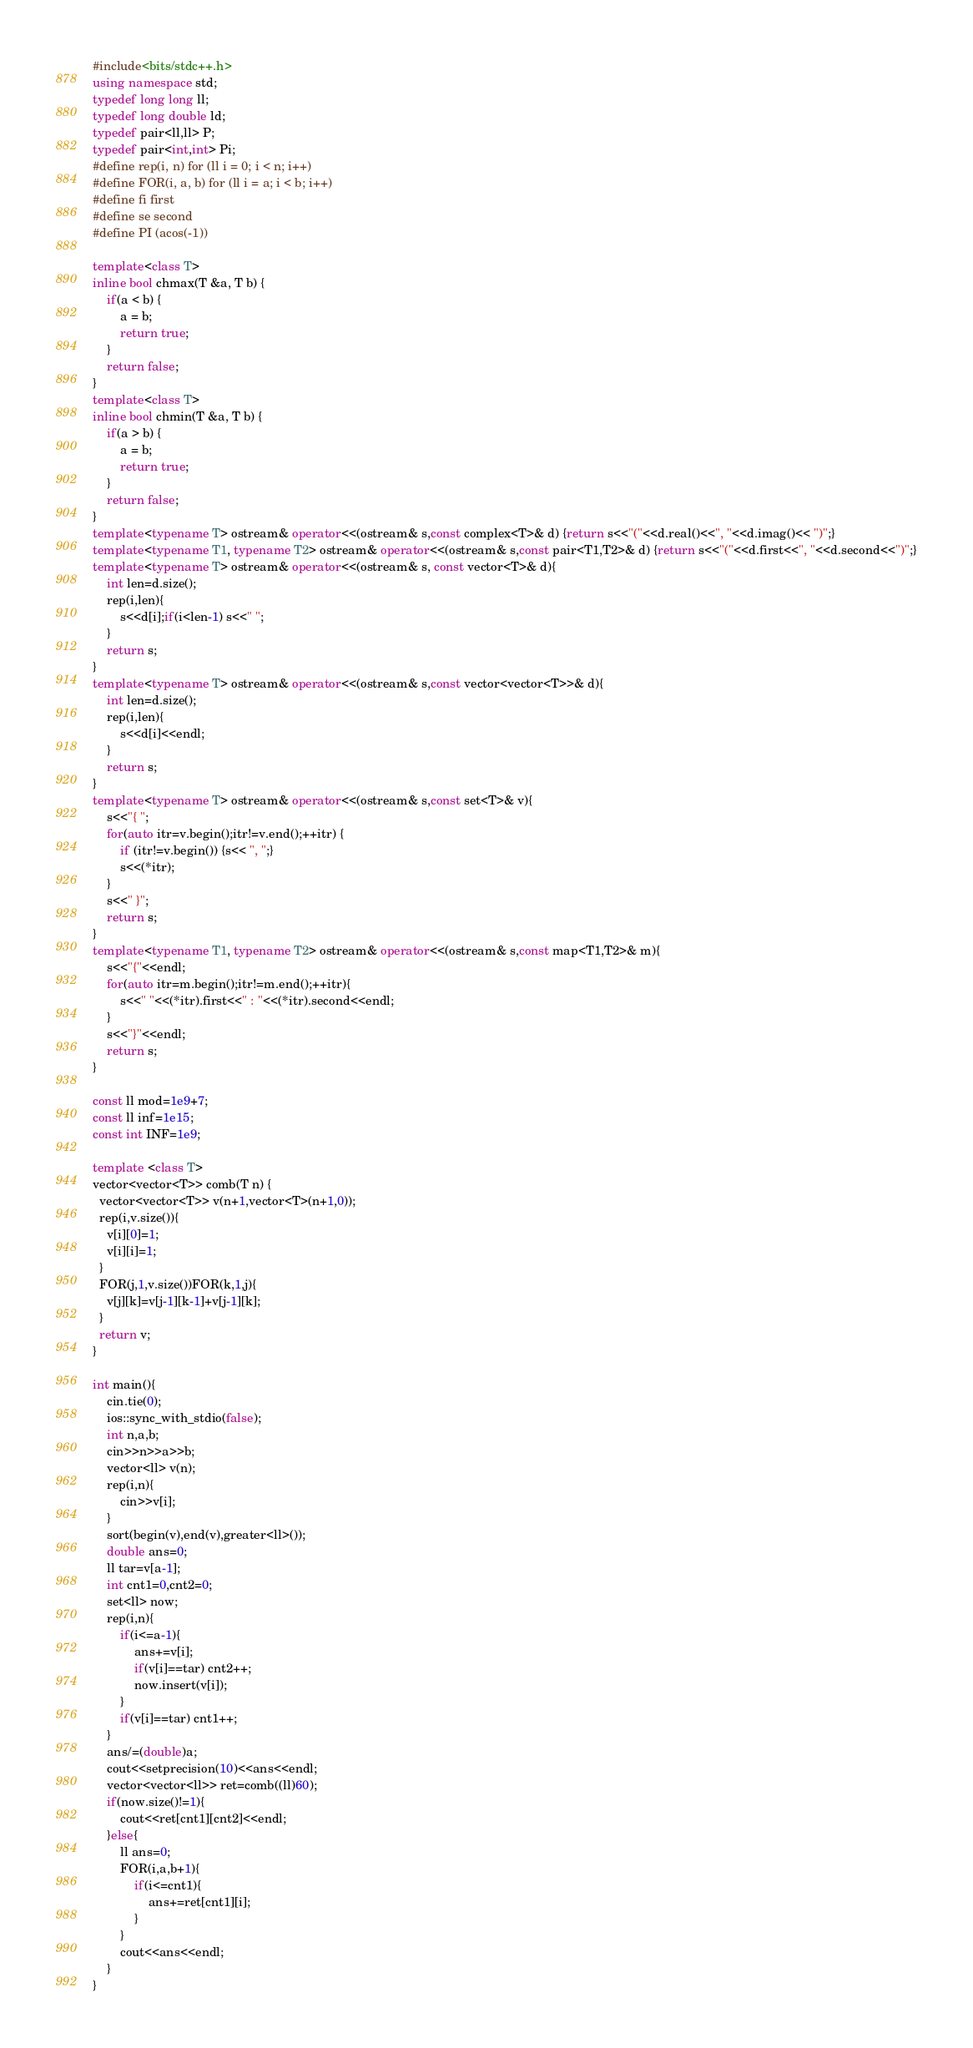<code> <loc_0><loc_0><loc_500><loc_500><_C++_>#include<bits/stdc++.h>
using namespace std;
typedef long long ll;
typedef long double ld;
typedef pair<ll,ll> P;
typedef pair<int,int> Pi;
#define rep(i, n) for (ll i = 0; i < n; i++)
#define FOR(i, a, b) for (ll i = a; i < b; i++)
#define fi first
#define se second
#define PI (acos(-1))

template<class T>
inline bool chmax(T &a, T b) {
    if(a < b) {
        a = b;
        return true;
    }
    return false;
}
template<class T>
inline bool chmin(T &a, T b) {
    if(a > b) {
        a = b;
        return true;
    }
    return false;
}
template<typename T> ostream& operator<<(ostream& s,const complex<T>& d) {return s<<"("<<d.real()<<", "<<d.imag()<< ")";}
template<typename T1, typename T2> ostream& operator<<(ostream& s,const pair<T1,T2>& d) {return s<<"("<<d.first<<", "<<d.second<<")";}
template<typename T> ostream& operator<<(ostream& s, const vector<T>& d){
	int len=d.size();
	rep(i,len){
		s<<d[i];if(i<len-1) s<<" ";
	}
	return s;
}
template<typename T> ostream& operator<<(ostream& s,const vector<vector<T>>& d){
	int len=d.size();
	rep(i,len){
		s<<d[i]<<endl;
	}
	return s;
}
template<typename T> ostream& operator<<(ostream& s,const set<T>& v){
	s<<"{ ";
	for(auto itr=v.begin();itr!=v.end();++itr) {
		if (itr!=v.begin()) {s<< ", ";}
		s<<(*itr);
	}
	s<<" }";
	return s;
}
template<typename T1, typename T2> ostream& operator<<(ostream& s,const map<T1,T2>& m){
	s<<"{"<<endl;
	for(auto itr=m.begin();itr!=m.end();++itr){
		s<<" "<<(*itr).first<<" : "<<(*itr).second<<endl;
	}
	s<<"}"<<endl;
	return s;
}

const ll mod=1e9+7;
const ll inf=1e15;
const int INF=1e9;

template <class T>
vector<vector<T>> comb(T n) {
  vector<vector<T>> v(n+1,vector<T>(n+1,0));
  rep(i,v.size()){
	v[i][0]=1;
	v[i][i]=1;
  }
  FOR(j,1,v.size())FOR(k,1,j){
	v[j][k]=v[j-1][k-1]+v[j-1][k];
  }
  return v;
}

int main(){
	cin.tie(0);
	ios::sync_with_stdio(false);
	int n,a,b;
	cin>>n>>a>>b;
	vector<ll> v(n);
	rep(i,n){
		cin>>v[i];
	}
	sort(begin(v),end(v),greater<ll>());
	double ans=0;
	ll tar=v[a-1];
	int cnt1=0,cnt2=0;
	set<ll> now;
	rep(i,n){
		if(i<=a-1){
			ans+=v[i];
			if(v[i]==tar) cnt2++;
			now.insert(v[i]);
		}
		if(v[i]==tar) cnt1++;
	}
	ans/=(double)a;
	cout<<setprecision(10)<<ans<<endl;
	vector<vector<ll>> ret=comb((ll)60);
	if(now.size()!=1){
		cout<<ret[cnt1][cnt2]<<endl;
	}else{
		ll ans=0;
		FOR(i,a,b+1){
			if(i<=cnt1){
				ans+=ret[cnt1][i];
			}
		}
		cout<<ans<<endl;
	}
}</code> 